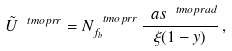<formula> <loc_0><loc_0><loc_500><loc_500>\tilde { U } ^ { \ t m o p { r r } } = N ^ { \ t m o p { r r } } _ { f _ { b } } \, \frac { \ a s ^ { \ t m o p { r a d } } } { \xi ( 1 - y ) } \, ,</formula> 